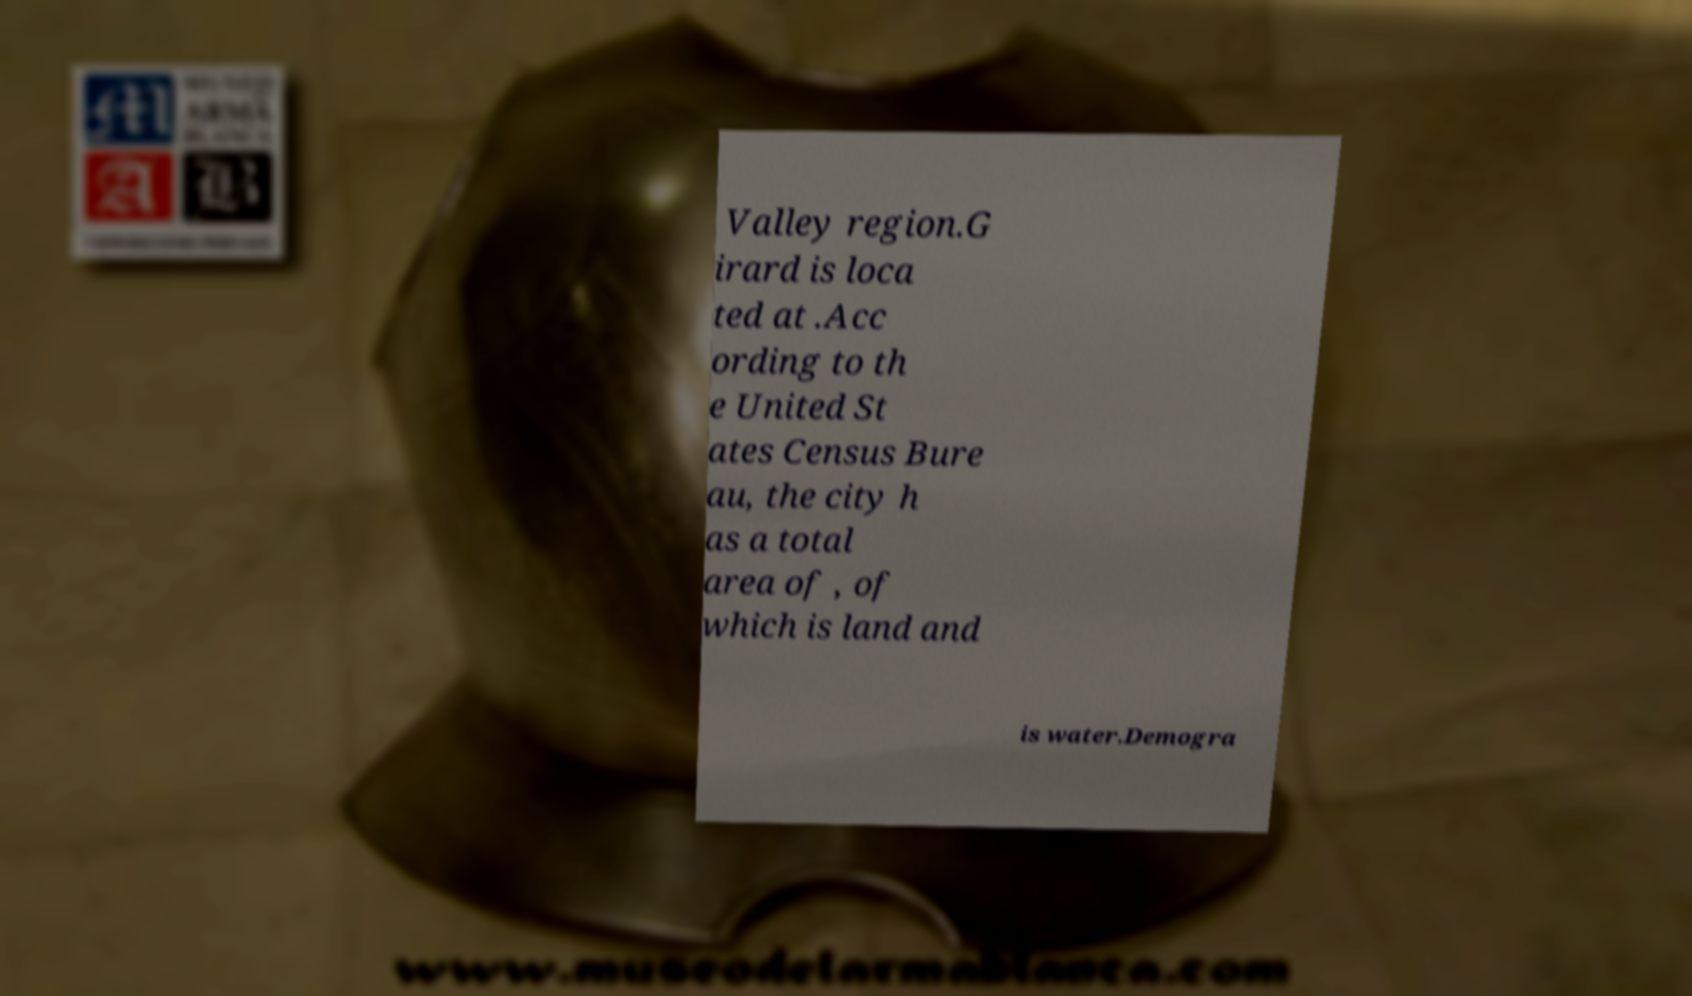For documentation purposes, I need the text within this image transcribed. Could you provide that? Valley region.G irard is loca ted at .Acc ording to th e United St ates Census Bure au, the city h as a total area of , of which is land and is water.Demogra 